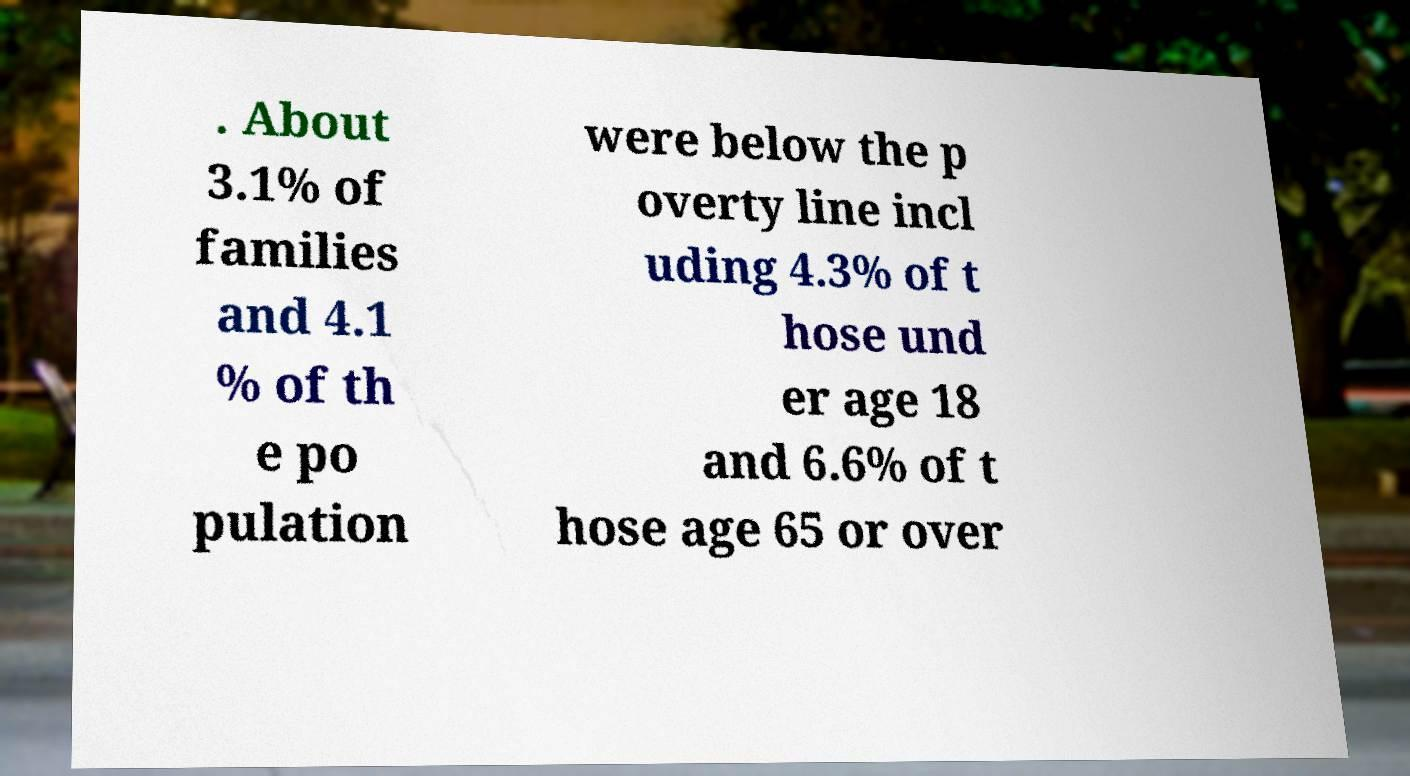Please read and relay the text visible in this image. What does it say? . About 3.1% of families and 4.1 % of th e po pulation were below the p overty line incl uding 4.3% of t hose und er age 18 and 6.6% of t hose age 65 or over 